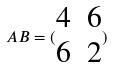<formula> <loc_0><loc_0><loc_500><loc_500>A B = ( \begin{matrix} 4 & 6 \\ 6 & 2 \end{matrix} )</formula> 